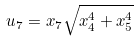Convert formula to latex. <formula><loc_0><loc_0><loc_500><loc_500>u _ { 7 } = x _ { 7 } \sqrt { x _ { 4 } ^ { 4 } + x _ { 5 } ^ { 4 } }</formula> 